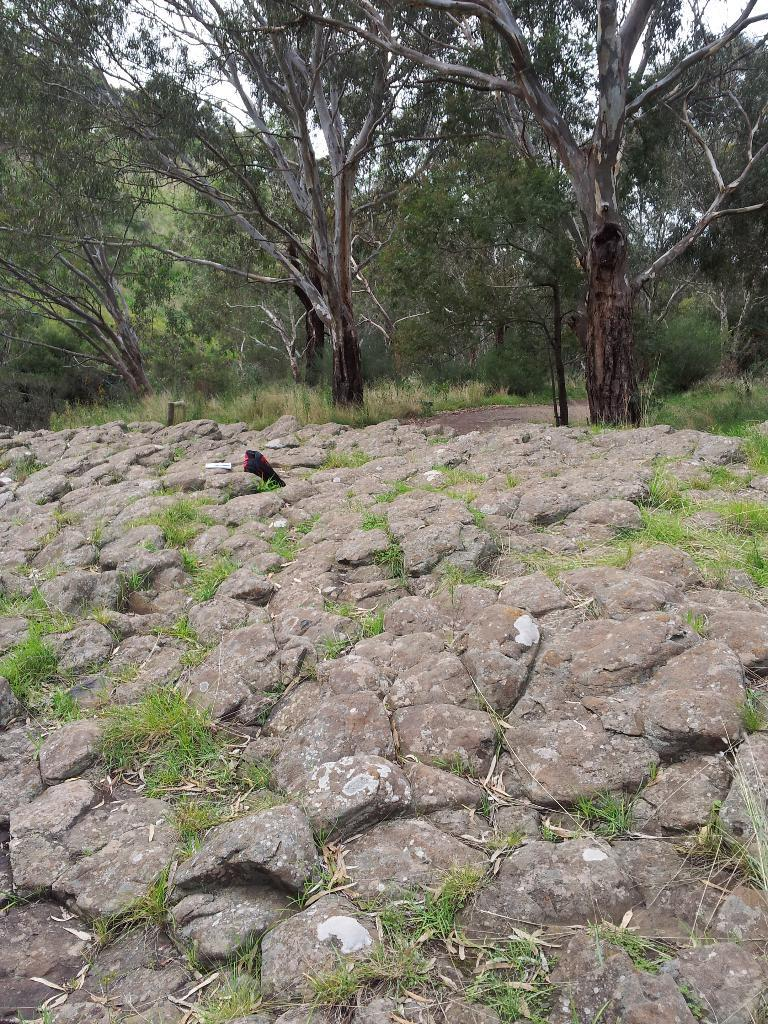What type of natural elements can be seen in the front of the image? There are rocks in the front of the image. What type of natural elements can be seen in the background of the image? There are trees in the background of the image. What man-made element can be seen in the background of the image? There is a road in the background of the image. What is visible in the sky in the background of the image? The sky is visible in the background of the image. What type of vegetable is growing on the road in the image? There are no vegetables present in the image, and the road is not a place where vegetables typically grow. What type of spacecraft can be seen in the image? There are no spacecraft present in the image; it features natural elements and a road. 